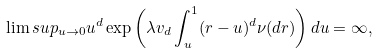Convert formula to latex. <formula><loc_0><loc_0><loc_500><loc_500>\lim s u p _ { u \to 0 } u ^ { d } \exp \left ( \lambda v _ { d } \int _ { u } ^ { 1 } ( r - u ) ^ { d } \nu ( d r ) \right ) d u = \infty ,</formula> 